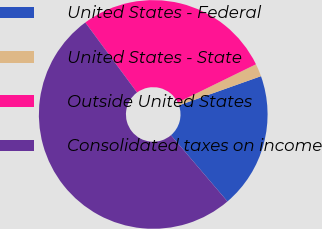Convert chart to OTSL. <chart><loc_0><loc_0><loc_500><loc_500><pie_chart><fcel>United States - Federal<fcel>United States - State<fcel>Outside United States<fcel>Consolidated taxes on income<nl><fcel>19.19%<fcel>1.8%<fcel>27.89%<fcel>51.12%<nl></chart> 